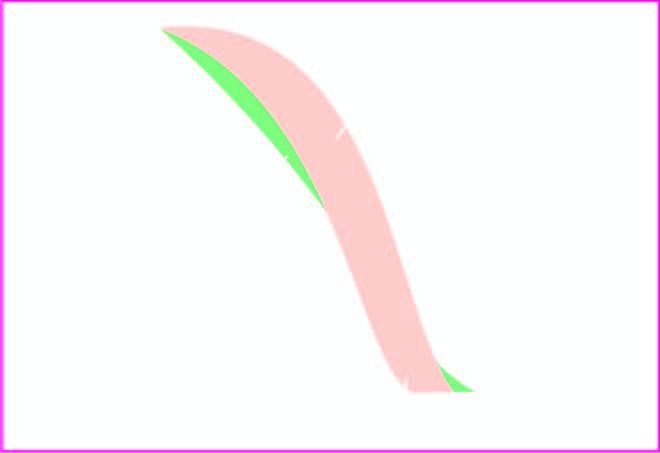did smotic fragility testing beta-thalassaemia major show decreased fragility?
Answer the question using a single word or phrase. Yes 